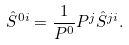<formula> <loc_0><loc_0><loc_500><loc_500>\hat { S } ^ { 0 i } = \frac { 1 } { P ^ { 0 } } P ^ { j } \hat { S } ^ { j i } .</formula> 